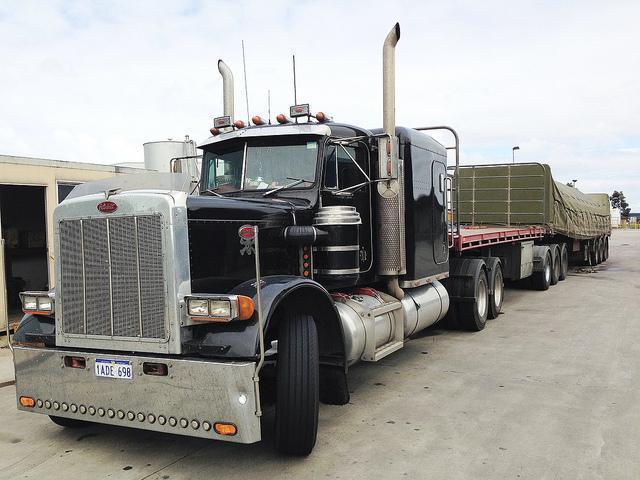How many horns does the truck have on each side?
Give a very brief answer. 2. 